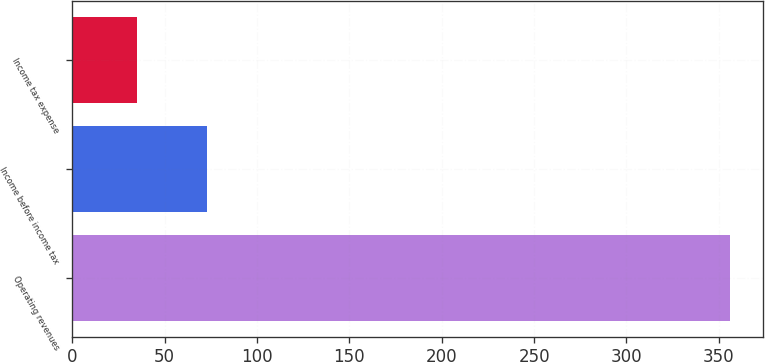Convert chart to OTSL. <chart><loc_0><loc_0><loc_500><loc_500><bar_chart><fcel>Operating revenues<fcel>Income before income tax<fcel>Income tax expense<nl><fcel>356<fcel>73<fcel>35<nl></chart> 